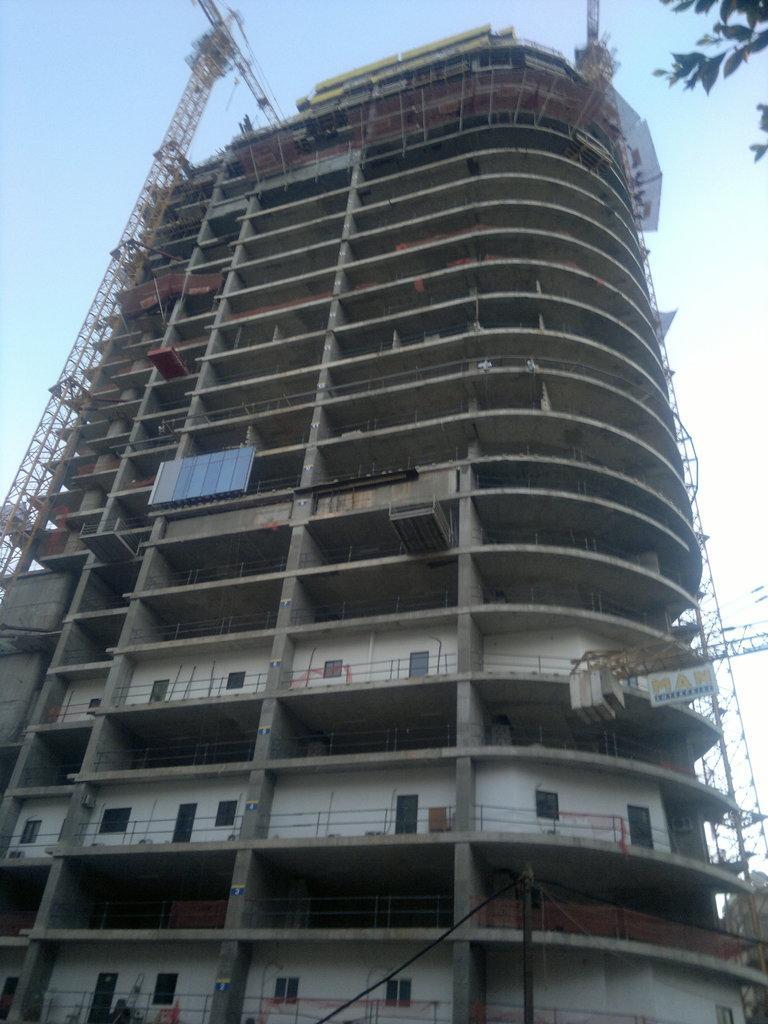In one or two sentences, can you explain what this image depicts? In this image we can see a building which is under construction and there are two crane machines and we can see some leaves and at the top we can see the sky. 